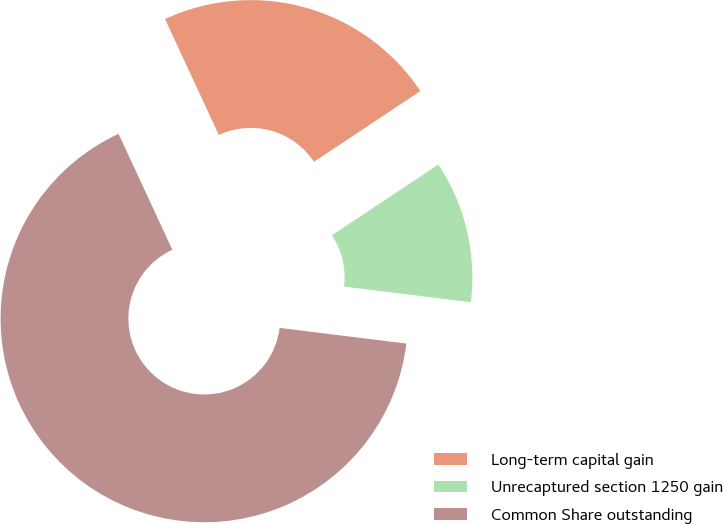<chart> <loc_0><loc_0><loc_500><loc_500><pie_chart><fcel>Long-term capital gain<fcel>Unrecaptured section 1250 gain<fcel>Common Share outstanding<nl><fcel>22.58%<fcel>11.29%<fcel>66.13%<nl></chart> 